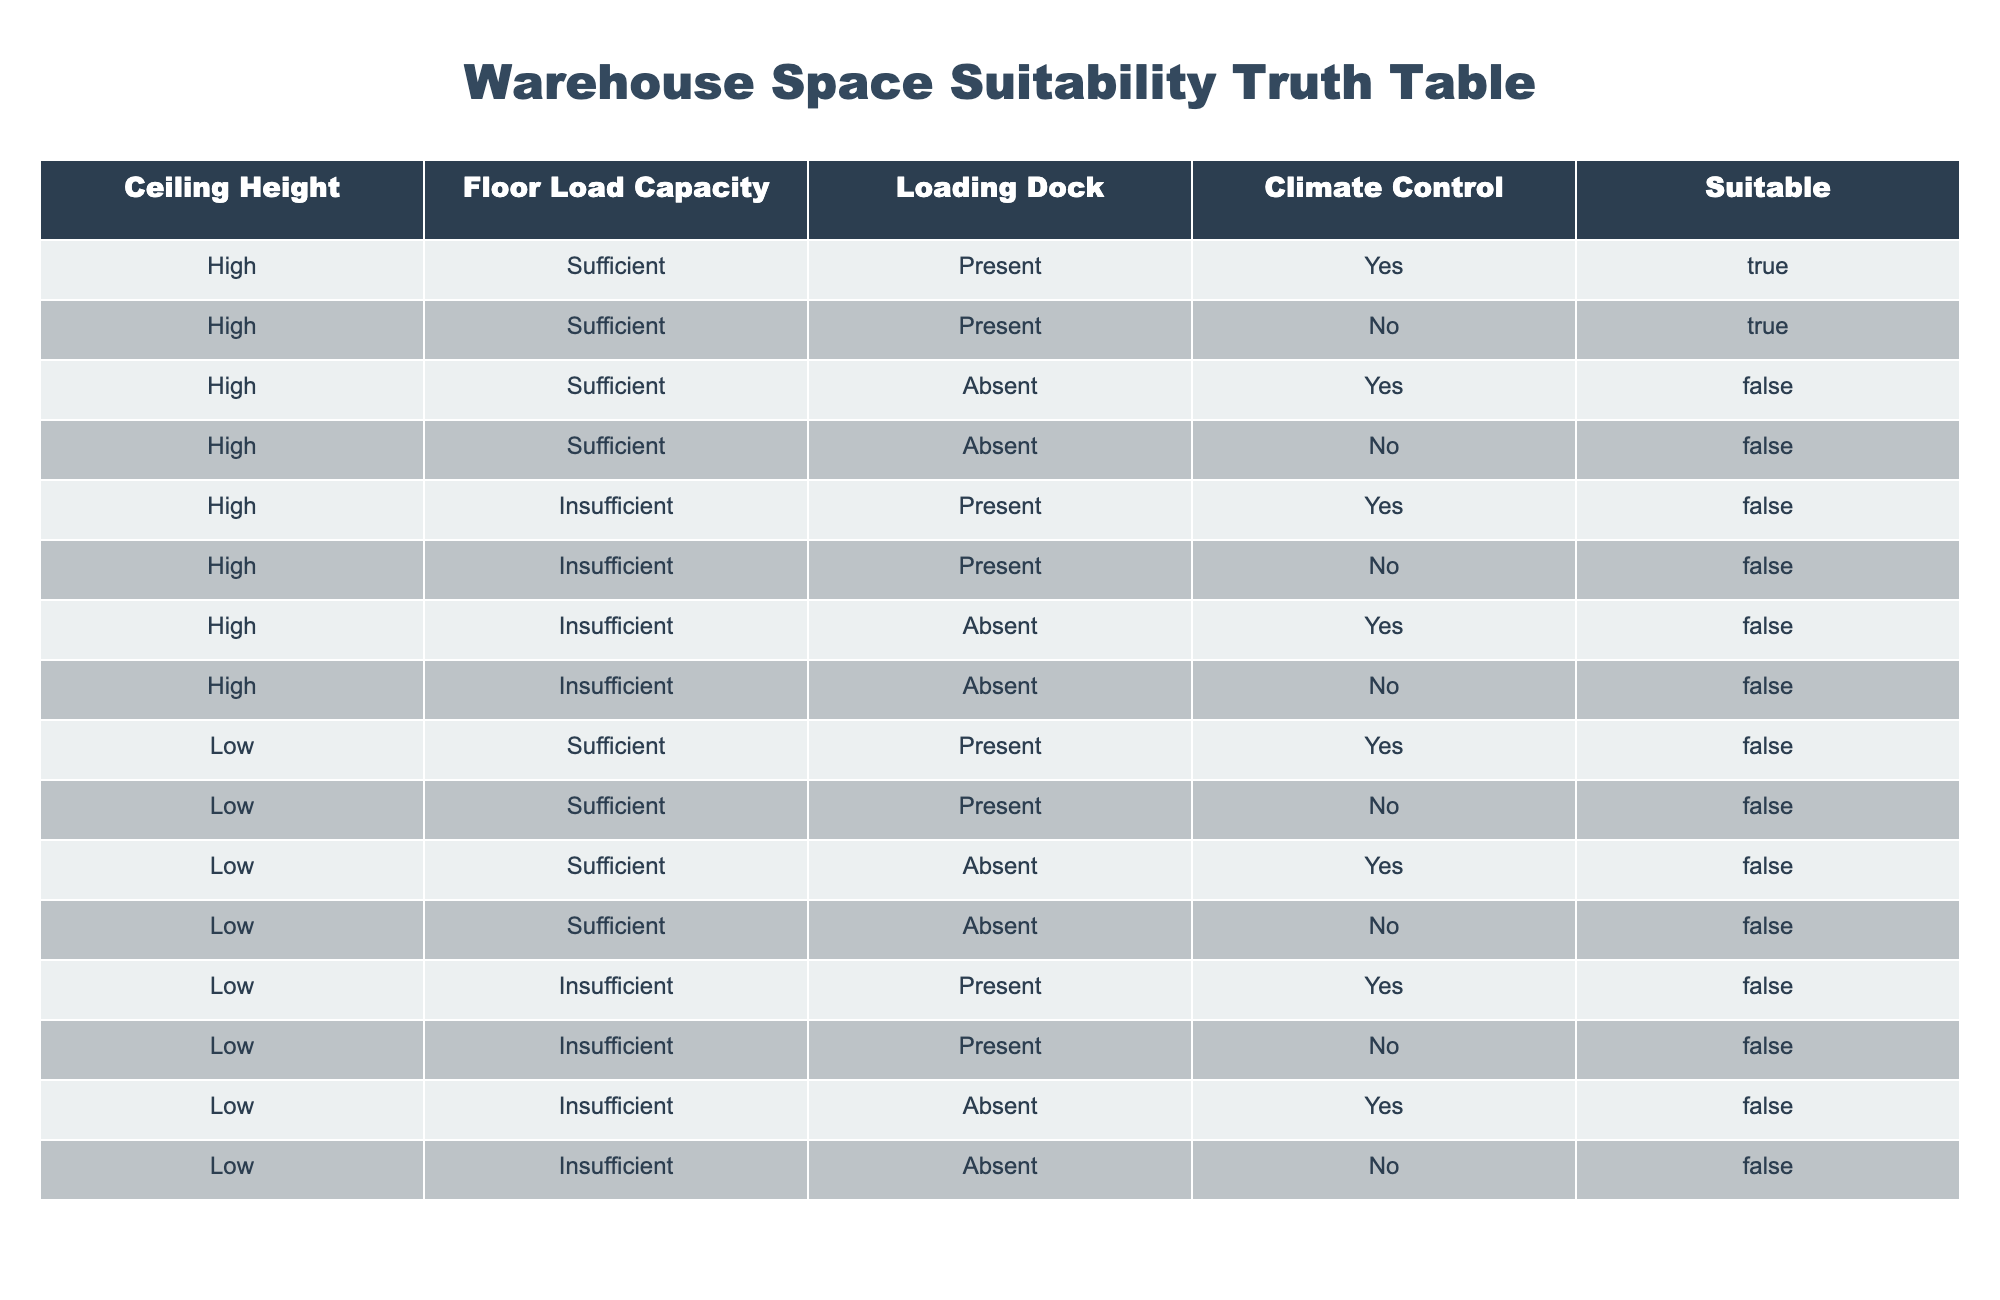What is the ceiling height requirement for a warehouse to be suitable? The table shows that for a warehouse to be deemed suitable, it must have a high ceiling height, as indicated by the "Suitable" column being True only in rows where "Ceiling Height" is High.
Answer: High How many configurations result in suitable warehouse spaces based on the given conditions? By examining the "Suitable" column, we identify that there are 2 configurations (High, Sufficient, Present, Yes and High, Sufficient, Present, No) that result in a True value.
Answer: 2 Is a warehouse with low floor load capacity and climate control suitable? Referring to the table, a warehouse with Low floor load capacity and any climate control (Yes or No) is unsuitable, as all entries with Low in the Floor Load Capacity column have a False in the Suitable column.
Answer: No For configurations with high ceiling height but insufficient floor load capacity, how many are suitable? In the table, all entries with both High ceiling height and Insufficient floor load capacity are not suitable, as evidenced by every corresponding row having a False value in the "Suitable" column.
Answer: 0 If a warehouse has sufficient floor load capacity, is it guaranteed to be suitable? The table reveals that having sufficient floor load capacity does not guarantee suitability, as seen in configurations with Low ceiling height which consistently show a False in the "Suitable" column despite sufficient load capacity.
Answer: No What percentage of configurations with climate control result in suitable warehouses? There are 3 configurations with climate control. Out of these, 2 are suitable, so the percentage is (2/3) * 100 = 66.67%.
Answer: 66.67% Are there any suitable configurations without a loading dock? The table shows the rows without a loading dock (Absent) for high ceiling height, only have two True entries, making it clear that suitable configurations do exist even without a loading dock.
Answer: Yes Among all configurations, which one leads to the highest likelihood of unsuitability? Analyzing the table, the configuration with Low ceiling height and Insufficient load capacity repeatedly leads to an unsuitability outcome, thus becoming the most likely candidate for unsuitability.
Answer: Low, Insufficient How many total configurations meet all conditions for warehouse suitability? By examining the table data, there are a total of 14 configurations presented, out of which 2 meet all conditions for warehouse suitability, which gives us our answer.
Answer: 2 